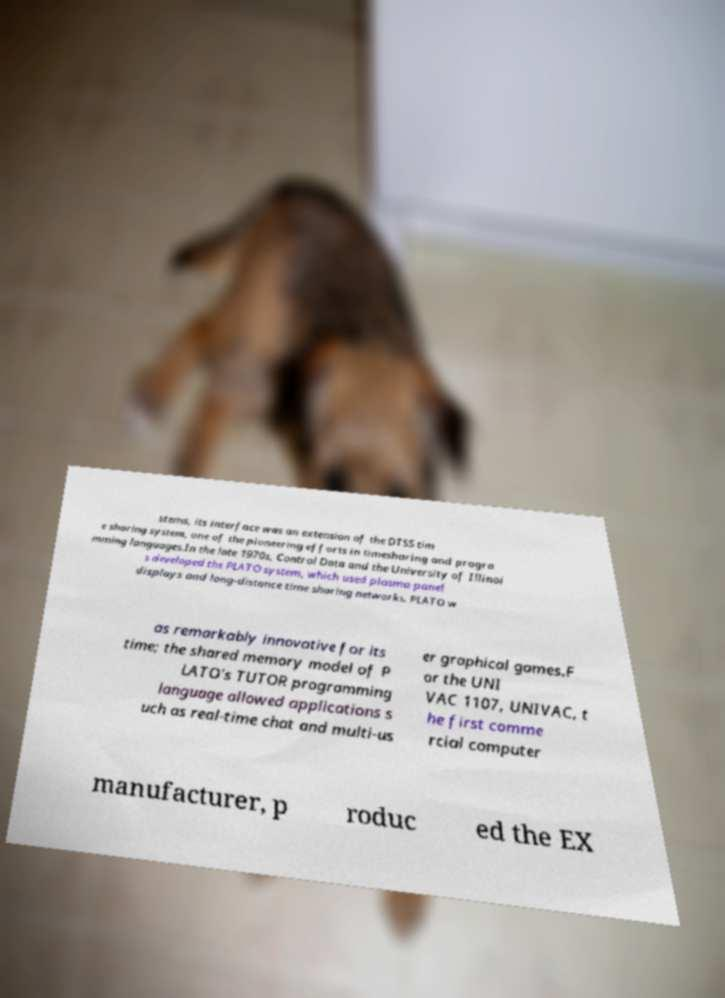Can you accurately transcribe the text from the provided image for me? stems, its interface was an extension of the DTSS tim e sharing system, one of the pioneering efforts in timesharing and progra mming languages.In the late 1970s, Control Data and the University of Illinoi s developed the PLATO system, which used plasma panel displays and long-distance time sharing networks. PLATO w as remarkably innovative for its time; the shared memory model of P LATO's TUTOR programming language allowed applications s uch as real-time chat and multi-us er graphical games.F or the UNI VAC 1107, UNIVAC, t he first comme rcial computer manufacturer, p roduc ed the EX 